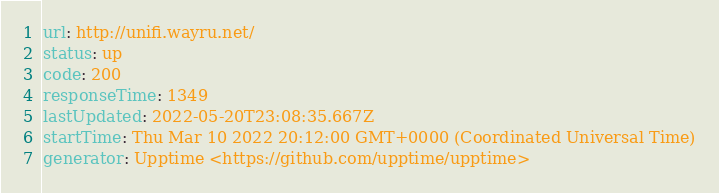<code> <loc_0><loc_0><loc_500><loc_500><_YAML_>url: http://unifi.wayru.net/
status: up
code: 200
responseTime: 1349
lastUpdated: 2022-05-20T23:08:35.667Z
startTime: Thu Mar 10 2022 20:12:00 GMT+0000 (Coordinated Universal Time)
generator: Upptime <https://github.com/upptime/upptime>
</code> 